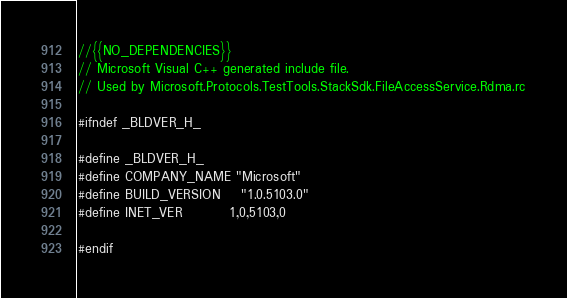Convert code to text. <code><loc_0><loc_0><loc_500><loc_500><_C_>//{{NO_DEPENDENCIES}}
// Microsoft Visual C++ generated include file.
// Used by Microsoft.Protocols.TestTools.StackSdk.FileAccessService.Rdma.rc

#ifndef _BLDVER_H_

#define _BLDVER_H_
#define COMPANY_NAME	"Microsoft"
#define BUILD_VERSION	"1.0.5103.0"
#define INET_VER         1,0,5103,0

#endif</code> 